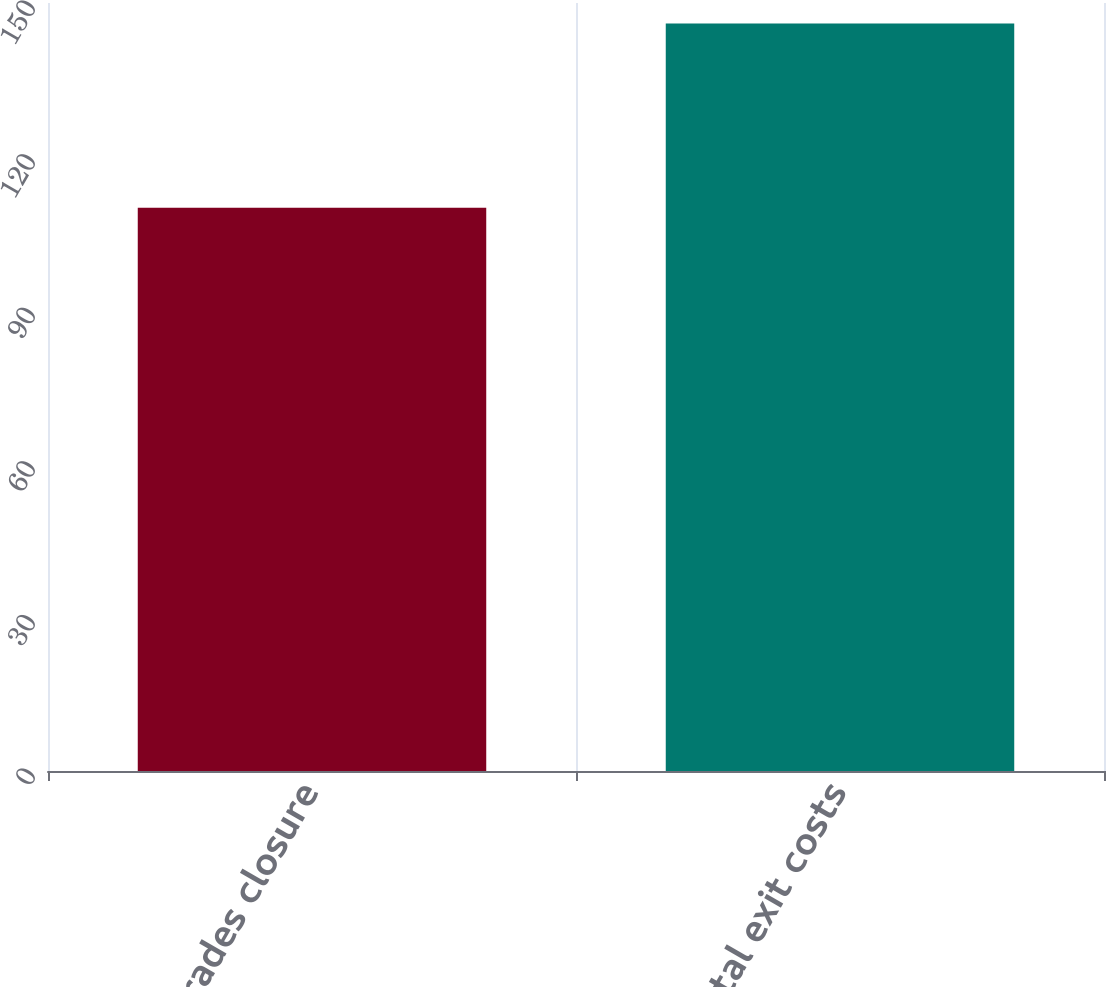Convert chart to OTSL. <chart><loc_0><loc_0><loc_500><loc_500><bar_chart><fcel>Varades closure<fcel>Total exit costs<nl><fcel>110<fcel>146<nl></chart> 